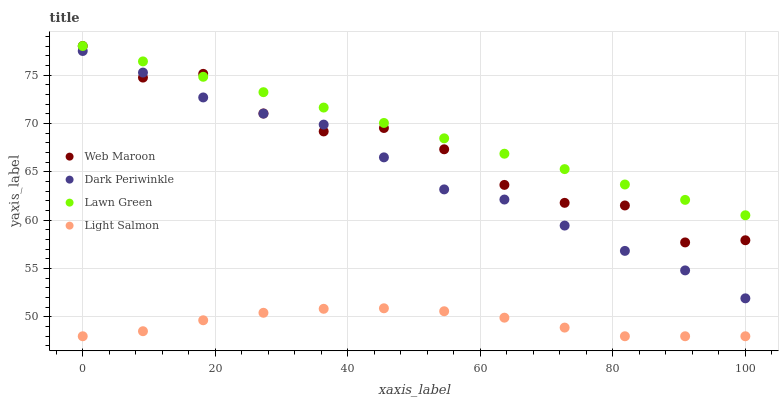Does Light Salmon have the minimum area under the curve?
Answer yes or no. Yes. Does Lawn Green have the maximum area under the curve?
Answer yes or no. Yes. Does Web Maroon have the minimum area under the curve?
Answer yes or no. No. Does Web Maroon have the maximum area under the curve?
Answer yes or no. No. Is Lawn Green the smoothest?
Answer yes or no. Yes. Is Web Maroon the roughest?
Answer yes or no. Yes. Is Light Salmon the smoothest?
Answer yes or no. No. Is Light Salmon the roughest?
Answer yes or no. No. Does Light Salmon have the lowest value?
Answer yes or no. Yes. Does Web Maroon have the lowest value?
Answer yes or no. No. Does Web Maroon have the highest value?
Answer yes or no. Yes. Does Light Salmon have the highest value?
Answer yes or no. No. Is Light Salmon less than Web Maroon?
Answer yes or no. Yes. Is Lawn Green greater than Dark Periwinkle?
Answer yes or no. Yes. Does Web Maroon intersect Dark Periwinkle?
Answer yes or no. Yes. Is Web Maroon less than Dark Periwinkle?
Answer yes or no. No. Is Web Maroon greater than Dark Periwinkle?
Answer yes or no. No. Does Light Salmon intersect Web Maroon?
Answer yes or no. No. 